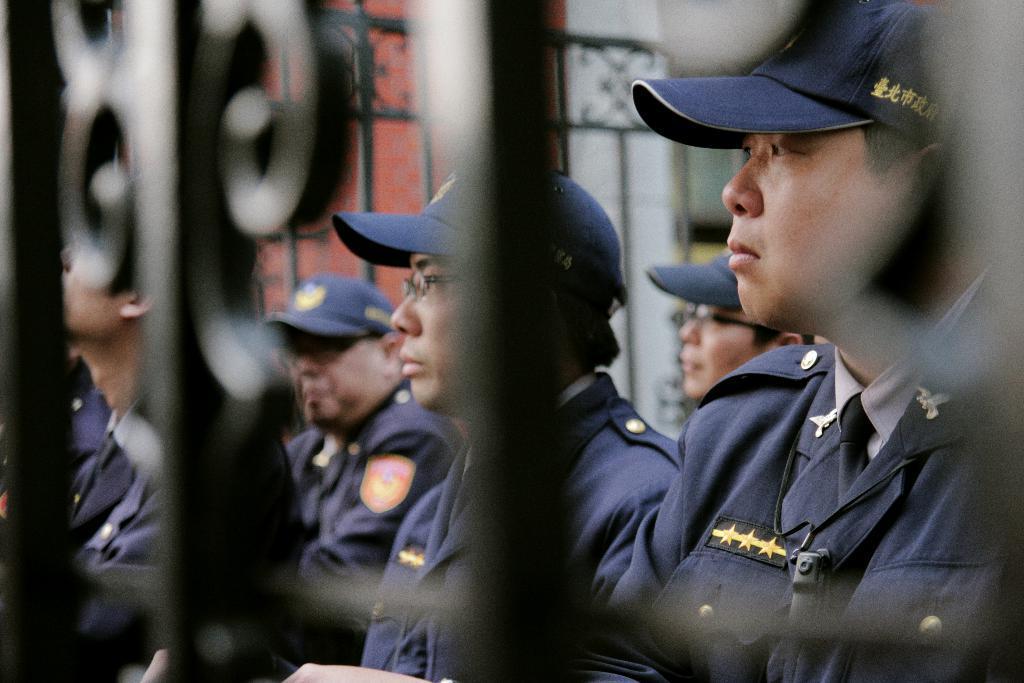Could you give a brief overview of what you see in this image? In this image, we can see people wearing uniforms and caps and some are wearing glasses and we can see grilles and a wall. 